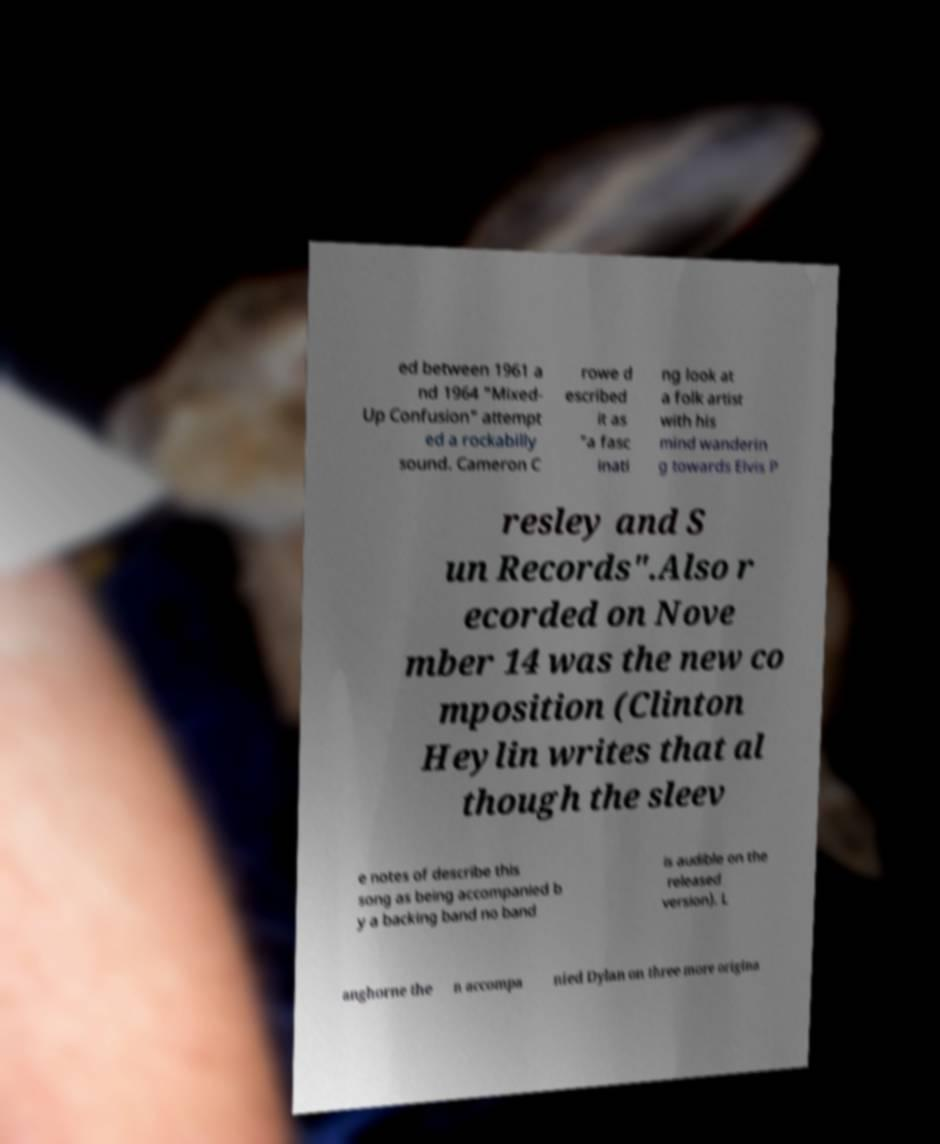There's text embedded in this image that I need extracted. Can you transcribe it verbatim? ed between 1961 a nd 1964 "Mixed- Up Confusion" attempt ed a rockabilly sound. Cameron C rowe d escribed it as "a fasc inati ng look at a folk artist with his mind wanderin g towards Elvis P resley and S un Records".Also r ecorded on Nove mber 14 was the new co mposition (Clinton Heylin writes that al though the sleev e notes of describe this song as being accompanied b y a backing band no band is audible on the released version). L anghorne the n accompa nied Dylan on three more origina 